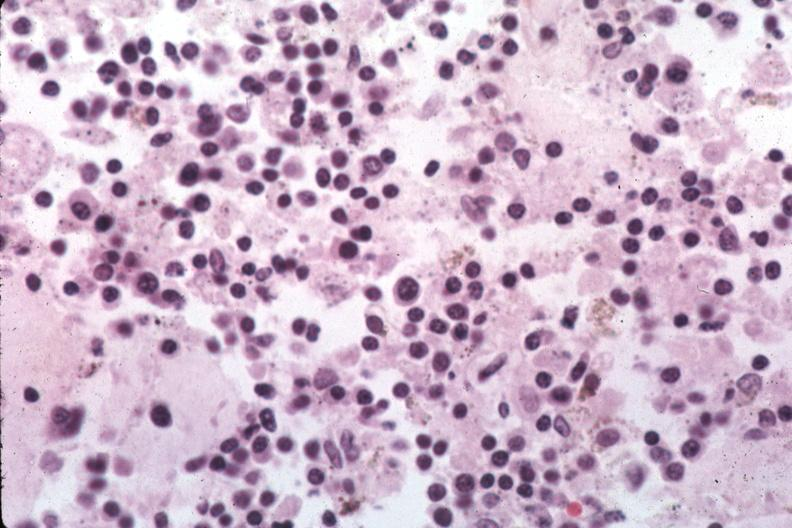s situs inversus present?
Answer the question using a single word or phrase. No 